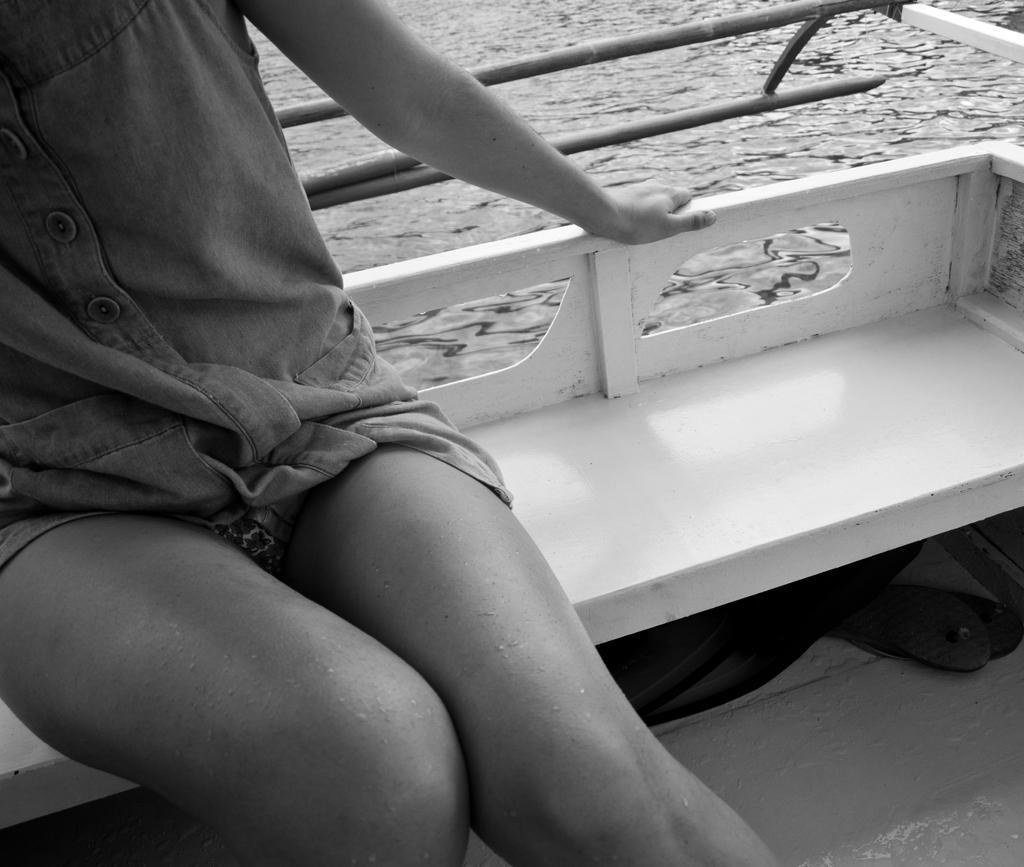Could you give a brief overview of what you see in this image? This is a black and white picture. In this picture, we see a person is sitting on the bench. We see a black color object under the bench. It might be a ship. Behind the person, we see the wooden sticks. In the background, we see water and this water might be in the lake. 